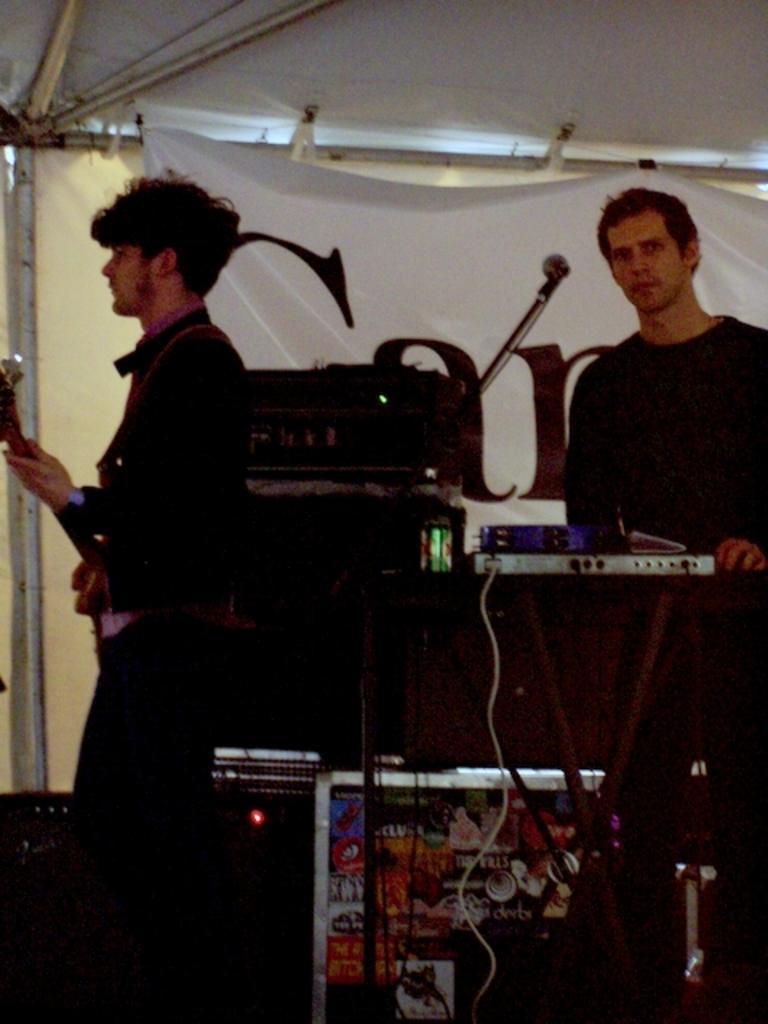In one or two sentences, can you explain what this image depicts? In the image they were two persons the left person he is playing guitar ,and the right person he is playing some musical instruments. And between them there are some instruments,and back of them there is a banner. 